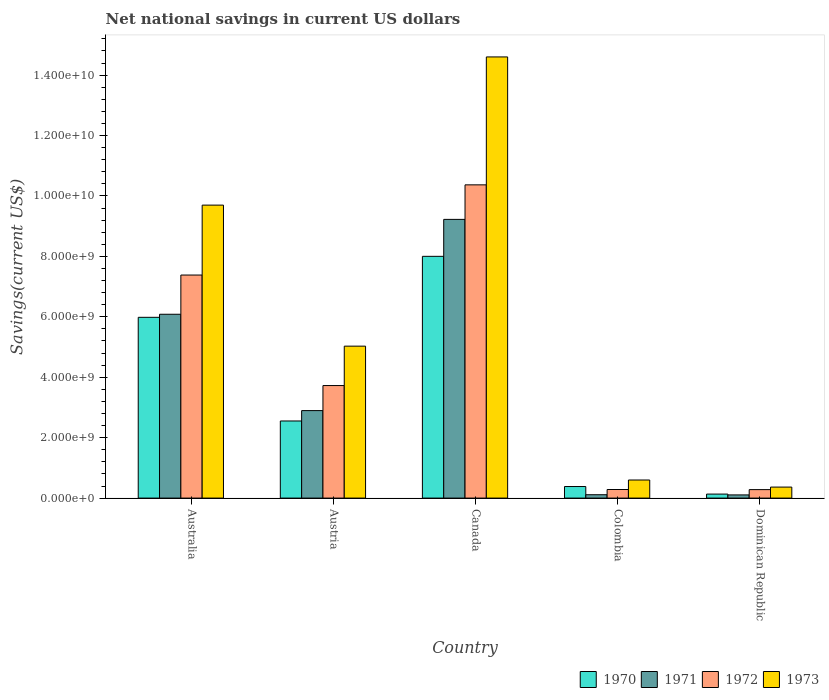Are the number of bars per tick equal to the number of legend labels?
Your response must be concise. Yes. Are the number of bars on each tick of the X-axis equal?
Keep it short and to the point. Yes. How many bars are there on the 3rd tick from the left?
Provide a succinct answer. 4. What is the label of the 5th group of bars from the left?
Keep it short and to the point. Dominican Republic. What is the net national savings in 1971 in Dominican Republic?
Offer a terse response. 1.05e+08. Across all countries, what is the maximum net national savings in 1971?
Your answer should be very brief. 9.23e+09. Across all countries, what is the minimum net national savings in 1973?
Your answer should be compact. 3.65e+08. In which country was the net national savings in 1972 maximum?
Give a very brief answer. Canada. In which country was the net national savings in 1971 minimum?
Your answer should be compact. Dominican Republic. What is the total net national savings in 1971 in the graph?
Ensure brevity in your answer.  1.84e+1. What is the difference between the net national savings in 1970 in Canada and that in Colombia?
Give a very brief answer. 7.62e+09. What is the difference between the net national savings in 1971 in Australia and the net national savings in 1972 in Austria?
Your answer should be very brief. 2.36e+09. What is the average net national savings in 1973 per country?
Your answer should be compact. 6.06e+09. What is the difference between the net national savings of/in 1970 and net national savings of/in 1971 in Austria?
Your answer should be very brief. -3.44e+08. What is the ratio of the net national savings in 1972 in Austria to that in Dominican Republic?
Keep it short and to the point. 13.28. Is the difference between the net national savings in 1970 in Australia and Canada greater than the difference between the net national savings in 1971 in Australia and Canada?
Provide a succinct answer. Yes. What is the difference between the highest and the second highest net national savings in 1970?
Offer a terse response. 3.43e+09. What is the difference between the highest and the lowest net national savings in 1970?
Make the answer very short. 7.87e+09. Is it the case that in every country, the sum of the net national savings in 1973 and net national savings in 1971 is greater than the net national savings in 1970?
Ensure brevity in your answer.  Yes. How many bars are there?
Your response must be concise. 20. Are all the bars in the graph horizontal?
Give a very brief answer. No. What is the difference between two consecutive major ticks on the Y-axis?
Make the answer very short. 2.00e+09. Are the values on the major ticks of Y-axis written in scientific E-notation?
Your answer should be very brief. Yes. Does the graph contain any zero values?
Your response must be concise. No. Does the graph contain grids?
Offer a very short reply. No. Where does the legend appear in the graph?
Your answer should be very brief. Bottom right. What is the title of the graph?
Provide a short and direct response. Net national savings in current US dollars. What is the label or title of the X-axis?
Your answer should be very brief. Country. What is the label or title of the Y-axis?
Provide a short and direct response. Savings(current US$). What is the Savings(current US$) in 1970 in Australia?
Give a very brief answer. 5.98e+09. What is the Savings(current US$) of 1971 in Australia?
Give a very brief answer. 6.09e+09. What is the Savings(current US$) in 1972 in Australia?
Make the answer very short. 7.38e+09. What is the Savings(current US$) in 1973 in Australia?
Your response must be concise. 9.70e+09. What is the Savings(current US$) in 1970 in Austria?
Make the answer very short. 2.55e+09. What is the Savings(current US$) of 1971 in Austria?
Offer a terse response. 2.90e+09. What is the Savings(current US$) of 1972 in Austria?
Your response must be concise. 3.73e+09. What is the Savings(current US$) of 1973 in Austria?
Provide a succinct answer. 5.03e+09. What is the Savings(current US$) of 1970 in Canada?
Provide a succinct answer. 8.00e+09. What is the Savings(current US$) in 1971 in Canada?
Make the answer very short. 9.23e+09. What is the Savings(current US$) in 1972 in Canada?
Make the answer very short. 1.04e+1. What is the Savings(current US$) in 1973 in Canada?
Ensure brevity in your answer.  1.46e+1. What is the Savings(current US$) of 1970 in Colombia?
Offer a very short reply. 3.83e+08. What is the Savings(current US$) in 1971 in Colombia?
Give a very brief answer. 1.11e+08. What is the Savings(current US$) of 1972 in Colombia?
Your response must be concise. 2.84e+08. What is the Savings(current US$) of 1973 in Colombia?
Keep it short and to the point. 5.98e+08. What is the Savings(current US$) of 1970 in Dominican Republic?
Your answer should be very brief. 1.33e+08. What is the Savings(current US$) of 1971 in Dominican Republic?
Make the answer very short. 1.05e+08. What is the Savings(current US$) of 1972 in Dominican Republic?
Provide a short and direct response. 2.80e+08. What is the Savings(current US$) in 1973 in Dominican Republic?
Provide a succinct answer. 3.65e+08. Across all countries, what is the maximum Savings(current US$) in 1970?
Keep it short and to the point. 8.00e+09. Across all countries, what is the maximum Savings(current US$) of 1971?
Provide a succinct answer. 9.23e+09. Across all countries, what is the maximum Savings(current US$) in 1972?
Give a very brief answer. 1.04e+1. Across all countries, what is the maximum Savings(current US$) of 1973?
Provide a short and direct response. 1.46e+1. Across all countries, what is the minimum Savings(current US$) in 1970?
Keep it short and to the point. 1.33e+08. Across all countries, what is the minimum Savings(current US$) of 1971?
Make the answer very short. 1.05e+08. Across all countries, what is the minimum Savings(current US$) of 1972?
Your response must be concise. 2.80e+08. Across all countries, what is the minimum Savings(current US$) of 1973?
Provide a short and direct response. 3.65e+08. What is the total Savings(current US$) of 1970 in the graph?
Offer a very short reply. 1.71e+1. What is the total Savings(current US$) of 1971 in the graph?
Give a very brief answer. 1.84e+1. What is the total Savings(current US$) of 1972 in the graph?
Your response must be concise. 2.20e+1. What is the total Savings(current US$) in 1973 in the graph?
Keep it short and to the point. 3.03e+1. What is the difference between the Savings(current US$) of 1970 in Australia and that in Austria?
Your answer should be very brief. 3.43e+09. What is the difference between the Savings(current US$) of 1971 in Australia and that in Austria?
Provide a succinct answer. 3.19e+09. What is the difference between the Savings(current US$) in 1972 in Australia and that in Austria?
Make the answer very short. 3.66e+09. What is the difference between the Savings(current US$) of 1973 in Australia and that in Austria?
Offer a terse response. 4.67e+09. What is the difference between the Savings(current US$) of 1970 in Australia and that in Canada?
Offer a very short reply. -2.02e+09. What is the difference between the Savings(current US$) in 1971 in Australia and that in Canada?
Keep it short and to the point. -3.14e+09. What is the difference between the Savings(current US$) in 1972 in Australia and that in Canada?
Ensure brevity in your answer.  -2.99e+09. What is the difference between the Savings(current US$) of 1973 in Australia and that in Canada?
Your response must be concise. -4.90e+09. What is the difference between the Savings(current US$) of 1970 in Australia and that in Colombia?
Keep it short and to the point. 5.60e+09. What is the difference between the Savings(current US$) of 1971 in Australia and that in Colombia?
Provide a short and direct response. 5.97e+09. What is the difference between the Savings(current US$) in 1972 in Australia and that in Colombia?
Offer a very short reply. 7.10e+09. What is the difference between the Savings(current US$) in 1973 in Australia and that in Colombia?
Provide a short and direct response. 9.10e+09. What is the difference between the Savings(current US$) of 1970 in Australia and that in Dominican Republic?
Offer a very short reply. 5.85e+09. What is the difference between the Savings(current US$) in 1971 in Australia and that in Dominican Republic?
Give a very brief answer. 5.98e+09. What is the difference between the Savings(current US$) of 1972 in Australia and that in Dominican Republic?
Give a very brief answer. 7.10e+09. What is the difference between the Savings(current US$) in 1973 in Australia and that in Dominican Republic?
Keep it short and to the point. 9.33e+09. What is the difference between the Savings(current US$) in 1970 in Austria and that in Canada?
Your response must be concise. -5.45e+09. What is the difference between the Savings(current US$) of 1971 in Austria and that in Canada?
Your answer should be very brief. -6.33e+09. What is the difference between the Savings(current US$) in 1972 in Austria and that in Canada?
Offer a very short reply. -6.64e+09. What is the difference between the Savings(current US$) in 1973 in Austria and that in Canada?
Your answer should be compact. -9.57e+09. What is the difference between the Savings(current US$) in 1970 in Austria and that in Colombia?
Your response must be concise. 2.17e+09. What is the difference between the Savings(current US$) of 1971 in Austria and that in Colombia?
Your answer should be compact. 2.78e+09. What is the difference between the Savings(current US$) of 1972 in Austria and that in Colombia?
Your answer should be very brief. 3.44e+09. What is the difference between the Savings(current US$) in 1973 in Austria and that in Colombia?
Keep it short and to the point. 4.43e+09. What is the difference between the Savings(current US$) in 1970 in Austria and that in Dominican Republic?
Make the answer very short. 2.42e+09. What is the difference between the Savings(current US$) of 1971 in Austria and that in Dominican Republic?
Provide a short and direct response. 2.79e+09. What is the difference between the Savings(current US$) in 1972 in Austria and that in Dominican Republic?
Your answer should be very brief. 3.44e+09. What is the difference between the Savings(current US$) of 1973 in Austria and that in Dominican Republic?
Ensure brevity in your answer.  4.66e+09. What is the difference between the Savings(current US$) in 1970 in Canada and that in Colombia?
Ensure brevity in your answer.  7.62e+09. What is the difference between the Savings(current US$) in 1971 in Canada and that in Colombia?
Offer a terse response. 9.11e+09. What is the difference between the Savings(current US$) in 1972 in Canada and that in Colombia?
Make the answer very short. 1.01e+1. What is the difference between the Savings(current US$) in 1973 in Canada and that in Colombia?
Offer a terse response. 1.40e+1. What is the difference between the Savings(current US$) of 1970 in Canada and that in Dominican Republic?
Give a very brief answer. 7.87e+09. What is the difference between the Savings(current US$) of 1971 in Canada and that in Dominican Republic?
Offer a very short reply. 9.12e+09. What is the difference between the Savings(current US$) in 1972 in Canada and that in Dominican Republic?
Give a very brief answer. 1.01e+1. What is the difference between the Savings(current US$) in 1973 in Canada and that in Dominican Republic?
Provide a succinct answer. 1.42e+1. What is the difference between the Savings(current US$) in 1970 in Colombia and that in Dominican Republic?
Your answer should be very brief. 2.50e+08. What is the difference between the Savings(current US$) in 1971 in Colombia and that in Dominican Republic?
Offer a terse response. 6.03e+06. What is the difference between the Savings(current US$) of 1972 in Colombia and that in Dominican Republic?
Provide a succinct answer. 3.48e+06. What is the difference between the Savings(current US$) of 1973 in Colombia and that in Dominican Republic?
Ensure brevity in your answer.  2.34e+08. What is the difference between the Savings(current US$) in 1970 in Australia and the Savings(current US$) in 1971 in Austria?
Give a very brief answer. 3.09e+09. What is the difference between the Savings(current US$) of 1970 in Australia and the Savings(current US$) of 1972 in Austria?
Your answer should be very brief. 2.26e+09. What is the difference between the Savings(current US$) in 1970 in Australia and the Savings(current US$) in 1973 in Austria?
Keep it short and to the point. 9.54e+08. What is the difference between the Savings(current US$) of 1971 in Australia and the Savings(current US$) of 1972 in Austria?
Offer a terse response. 2.36e+09. What is the difference between the Savings(current US$) of 1971 in Australia and the Savings(current US$) of 1973 in Austria?
Offer a terse response. 1.06e+09. What is the difference between the Savings(current US$) in 1972 in Australia and the Savings(current US$) in 1973 in Austria?
Offer a very short reply. 2.35e+09. What is the difference between the Savings(current US$) in 1970 in Australia and the Savings(current US$) in 1971 in Canada?
Give a very brief answer. -3.24e+09. What is the difference between the Savings(current US$) in 1970 in Australia and the Savings(current US$) in 1972 in Canada?
Provide a short and direct response. -4.38e+09. What is the difference between the Savings(current US$) in 1970 in Australia and the Savings(current US$) in 1973 in Canada?
Keep it short and to the point. -8.62e+09. What is the difference between the Savings(current US$) of 1971 in Australia and the Savings(current US$) of 1972 in Canada?
Your answer should be compact. -4.28e+09. What is the difference between the Savings(current US$) in 1971 in Australia and the Savings(current US$) in 1973 in Canada?
Provide a succinct answer. -8.52e+09. What is the difference between the Savings(current US$) in 1972 in Australia and the Savings(current US$) in 1973 in Canada?
Your response must be concise. -7.22e+09. What is the difference between the Savings(current US$) in 1970 in Australia and the Savings(current US$) in 1971 in Colombia?
Offer a terse response. 5.87e+09. What is the difference between the Savings(current US$) in 1970 in Australia and the Savings(current US$) in 1972 in Colombia?
Make the answer very short. 5.70e+09. What is the difference between the Savings(current US$) in 1970 in Australia and the Savings(current US$) in 1973 in Colombia?
Make the answer very short. 5.38e+09. What is the difference between the Savings(current US$) in 1971 in Australia and the Savings(current US$) in 1972 in Colombia?
Offer a very short reply. 5.80e+09. What is the difference between the Savings(current US$) in 1971 in Australia and the Savings(current US$) in 1973 in Colombia?
Provide a short and direct response. 5.49e+09. What is the difference between the Savings(current US$) of 1972 in Australia and the Savings(current US$) of 1973 in Colombia?
Ensure brevity in your answer.  6.78e+09. What is the difference between the Savings(current US$) of 1970 in Australia and the Savings(current US$) of 1971 in Dominican Republic?
Keep it short and to the point. 5.88e+09. What is the difference between the Savings(current US$) in 1970 in Australia and the Savings(current US$) in 1972 in Dominican Republic?
Your response must be concise. 5.70e+09. What is the difference between the Savings(current US$) in 1970 in Australia and the Savings(current US$) in 1973 in Dominican Republic?
Provide a short and direct response. 5.62e+09. What is the difference between the Savings(current US$) of 1971 in Australia and the Savings(current US$) of 1972 in Dominican Republic?
Your answer should be compact. 5.80e+09. What is the difference between the Savings(current US$) of 1971 in Australia and the Savings(current US$) of 1973 in Dominican Republic?
Ensure brevity in your answer.  5.72e+09. What is the difference between the Savings(current US$) in 1972 in Australia and the Savings(current US$) in 1973 in Dominican Republic?
Ensure brevity in your answer.  7.02e+09. What is the difference between the Savings(current US$) in 1970 in Austria and the Savings(current US$) in 1971 in Canada?
Your response must be concise. -6.67e+09. What is the difference between the Savings(current US$) in 1970 in Austria and the Savings(current US$) in 1972 in Canada?
Your answer should be very brief. -7.82e+09. What is the difference between the Savings(current US$) of 1970 in Austria and the Savings(current US$) of 1973 in Canada?
Ensure brevity in your answer.  -1.20e+1. What is the difference between the Savings(current US$) in 1971 in Austria and the Savings(current US$) in 1972 in Canada?
Provide a succinct answer. -7.47e+09. What is the difference between the Savings(current US$) of 1971 in Austria and the Savings(current US$) of 1973 in Canada?
Your answer should be very brief. -1.17e+1. What is the difference between the Savings(current US$) in 1972 in Austria and the Savings(current US$) in 1973 in Canada?
Your response must be concise. -1.09e+1. What is the difference between the Savings(current US$) in 1970 in Austria and the Savings(current US$) in 1971 in Colombia?
Provide a short and direct response. 2.44e+09. What is the difference between the Savings(current US$) in 1970 in Austria and the Savings(current US$) in 1972 in Colombia?
Give a very brief answer. 2.27e+09. What is the difference between the Savings(current US$) in 1970 in Austria and the Savings(current US$) in 1973 in Colombia?
Your response must be concise. 1.95e+09. What is the difference between the Savings(current US$) in 1971 in Austria and the Savings(current US$) in 1972 in Colombia?
Make the answer very short. 2.61e+09. What is the difference between the Savings(current US$) in 1971 in Austria and the Savings(current US$) in 1973 in Colombia?
Provide a succinct answer. 2.30e+09. What is the difference between the Savings(current US$) in 1972 in Austria and the Savings(current US$) in 1973 in Colombia?
Offer a terse response. 3.13e+09. What is the difference between the Savings(current US$) of 1970 in Austria and the Savings(current US$) of 1971 in Dominican Republic?
Your answer should be compact. 2.45e+09. What is the difference between the Savings(current US$) in 1970 in Austria and the Savings(current US$) in 1972 in Dominican Republic?
Your answer should be very brief. 2.27e+09. What is the difference between the Savings(current US$) in 1970 in Austria and the Savings(current US$) in 1973 in Dominican Republic?
Give a very brief answer. 2.19e+09. What is the difference between the Savings(current US$) in 1971 in Austria and the Savings(current US$) in 1972 in Dominican Republic?
Give a very brief answer. 2.62e+09. What is the difference between the Savings(current US$) of 1971 in Austria and the Savings(current US$) of 1973 in Dominican Republic?
Offer a terse response. 2.53e+09. What is the difference between the Savings(current US$) of 1972 in Austria and the Savings(current US$) of 1973 in Dominican Republic?
Ensure brevity in your answer.  3.36e+09. What is the difference between the Savings(current US$) in 1970 in Canada and the Savings(current US$) in 1971 in Colombia?
Offer a very short reply. 7.89e+09. What is the difference between the Savings(current US$) in 1970 in Canada and the Savings(current US$) in 1972 in Colombia?
Provide a succinct answer. 7.72e+09. What is the difference between the Savings(current US$) of 1970 in Canada and the Savings(current US$) of 1973 in Colombia?
Make the answer very short. 7.40e+09. What is the difference between the Savings(current US$) in 1971 in Canada and the Savings(current US$) in 1972 in Colombia?
Keep it short and to the point. 8.94e+09. What is the difference between the Savings(current US$) of 1971 in Canada and the Savings(current US$) of 1973 in Colombia?
Provide a succinct answer. 8.63e+09. What is the difference between the Savings(current US$) of 1972 in Canada and the Savings(current US$) of 1973 in Colombia?
Provide a short and direct response. 9.77e+09. What is the difference between the Savings(current US$) in 1970 in Canada and the Savings(current US$) in 1971 in Dominican Republic?
Your response must be concise. 7.90e+09. What is the difference between the Savings(current US$) in 1970 in Canada and the Savings(current US$) in 1972 in Dominican Republic?
Offer a terse response. 7.72e+09. What is the difference between the Savings(current US$) in 1970 in Canada and the Savings(current US$) in 1973 in Dominican Republic?
Offer a terse response. 7.64e+09. What is the difference between the Savings(current US$) in 1971 in Canada and the Savings(current US$) in 1972 in Dominican Republic?
Your answer should be compact. 8.94e+09. What is the difference between the Savings(current US$) of 1971 in Canada and the Savings(current US$) of 1973 in Dominican Republic?
Provide a succinct answer. 8.86e+09. What is the difference between the Savings(current US$) in 1972 in Canada and the Savings(current US$) in 1973 in Dominican Republic?
Your response must be concise. 1.00e+1. What is the difference between the Savings(current US$) of 1970 in Colombia and the Savings(current US$) of 1971 in Dominican Republic?
Make the answer very short. 2.77e+08. What is the difference between the Savings(current US$) in 1970 in Colombia and the Savings(current US$) in 1972 in Dominican Republic?
Ensure brevity in your answer.  1.02e+08. What is the difference between the Savings(current US$) in 1970 in Colombia and the Savings(current US$) in 1973 in Dominican Republic?
Ensure brevity in your answer.  1.82e+07. What is the difference between the Savings(current US$) in 1971 in Colombia and the Savings(current US$) in 1972 in Dominican Republic?
Keep it short and to the point. -1.69e+08. What is the difference between the Savings(current US$) in 1971 in Colombia and the Savings(current US$) in 1973 in Dominican Republic?
Your answer should be very brief. -2.53e+08. What is the difference between the Savings(current US$) in 1972 in Colombia and the Savings(current US$) in 1973 in Dominican Republic?
Offer a terse response. -8.05e+07. What is the average Savings(current US$) in 1970 per country?
Provide a short and direct response. 3.41e+09. What is the average Savings(current US$) of 1971 per country?
Your answer should be very brief. 3.68e+09. What is the average Savings(current US$) in 1972 per country?
Your response must be concise. 4.41e+09. What is the average Savings(current US$) of 1973 per country?
Ensure brevity in your answer.  6.06e+09. What is the difference between the Savings(current US$) of 1970 and Savings(current US$) of 1971 in Australia?
Your answer should be compact. -1.02e+08. What is the difference between the Savings(current US$) in 1970 and Savings(current US$) in 1972 in Australia?
Your response must be concise. -1.40e+09. What is the difference between the Savings(current US$) of 1970 and Savings(current US$) of 1973 in Australia?
Offer a very short reply. -3.71e+09. What is the difference between the Savings(current US$) of 1971 and Savings(current US$) of 1972 in Australia?
Keep it short and to the point. -1.30e+09. What is the difference between the Savings(current US$) in 1971 and Savings(current US$) in 1973 in Australia?
Make the answer very short. -3.61e+09. What is the difference between the Savings(current US$) of 1972 and Savings(current US$) of 1973 in Australia?
Keep it short and to the point. -2.31e+09. What is the difference between the Savings(current US$) of 1970 and Savings(current US$) of 1971 in Austria?
Offer a terse response. -3.44e+08. What is the difference between the Savings(current US$) of 1970 and Savings(current US$) of 1972 in Austria?
Your response must be concise. -1.17e+09. What is the difference between the Savings(current US$) in 1970 and Savings(current US$) in 1973 in Austria?
Ensure brevity in your answer.  -2.48e+09. What is the difference between the Savings(current US$) in 1971 and Savings(current US$) in 1972 in Austria?
Ensure brevity in your answer.  -8.29e+08. What is the difference between the Savings(current US$) in 1971 and Savings(current US$) in 1973 in Austria?
Your answer should be very brief. -2.13e+09. What is the difference between the Savings(current US$) of 1972 and Savings(current US$) of 1973 in Austria?
Give a very brief answer. -1.30e+09. What is the difference between the Savings(current US$) in 1970 and Savings(current US$) in 1971 in Canada?
Keep it short and to the point. -1.22e+09. What is the difference between the Savings(current US$) of 1970 and Savings(current US$) of 1972 in Canada?
Give a very brief answer. -2.37e+09. What is the difference between the Savings(current US$) in 1970 and Savings(current US$) in 1973 in Canada?
Offer a very short reply. -6.60e+09. What is the difference between the Savings(current US$) of 1971 and Savings(current US$) of 1972 in Canada?
Your response must be concise. -1.14e+09. What is the difference between the Savings(current US$) of 1971 and Savings(current US$) of 1973 in Canada?
Keep it short and to the point. -5.38e+09. What is the difference between the Savings(current US$) in 1972 and Savings(current US$) in 1973 in Canada?
Ensure brevity in your answer.  -4.23e+09. What is the difference between the Savings(current US$) of 1970 and Savings(current US$) of 1971 in Colombia?
Provide a succinct answer. 2.71e+08. What is the difference between the Savings(current US$) in 1970 and Savings(current US$) in 1972 in Colombia?
Give a very brief answer. 9.87e+07. What is the difference between the Savings(current US$) in 1970 and Savings(current US$) in 1973 in Colombia?
Your answer should be compact. -2.16e+08. What is the difference between the Savings(current US$) of 1971 and Savings(current US$) of 1972 in Colombia?
Give a very brief answer. -1.73e+08. What is the difference between the Savings(current US$) in 1971 and Savings(current US$) in 1973 in Colombia?
Keep it short and to the point. -4.87e+08. What is the difference between the Savings(current US$) of 1972 and Savings(current US$) of 1973 in Colombia?
Provide a succinct answer. -3.14e+08. What is the difference between the Savings(current US$) of 1970 and Savings(current US$) of 1971 in Dominican Republic?
Offer a terse response. 2.74e+07. What is the difference between the Savings(current US$) of 1970 and Savings(current US$) of 1972 in Dominican Republic?
Ensure brevity in your answer.  -1.48e+08. What is the difference between the Savings(current US$) in 1970 and Savings(current US$) in 1973 in Dominican Republic?
Your response must be concise. -2.32e+08. What is the difference between the Savings(current US$) of 1971 and Savings(current US$) of 1972 in Dominican Republic?
Keep it short and to the point. -1.75e+08. What is the difference between the Savings(current US$) of 1971 and Savings(current US$) of 1973 in Dominican Republic?
Offer a terse response. -2.59e+08. What is the difference between the Savings(current US$) of 1972 and Savings(current US$) of 1973 in Dominican Republic?
Keep it short and to the point. -8.40e+07. What is the ratio of the Savings(current US$) of 1970 in Australia to that in Austria?
Your answer should be compact. 2.34. What is the ratio of the Savings(current US$) in 1971 in Australia to that in Austria?
Your answer should be compact. 2.1. What is the ratio of the Savings(current US$) in 1972 in Australia to that in Austria?
Provide a short and direct response. 1.98. What is the ratio of the Savings(current US$) in 1973 in Australia to that in Austria?
Your answer should be very brief. 1.93. What is the ratio of the Savings(current US$) of 1970 in Australia to that in Canada?
Offer a very short reply. 0.75. What is the ratio of the Savings(current US$) in 1971 in Australia to that in Canada?
Offer a very short reply. 0.66. What is the ratio of the Savings(current US$) in 1972 in Australia to that in Canada?
Your answer should be compact. 0.71. What is the ratio of the Savings(current US$) of 1973 in Australia to that in Canada?
Provide a succinct answer. 0.66. What is the ratio of the Savings(current US$) in 1970 in Australia to that in Colombia?
Offer a terse response. 15.64. What is the ratio of the Savings(current US$) of 1971 in Australia to that in Colombia?
Your answer should be compact. 54.61. What is the ratio of the Savings(current US$) of 1972 in Australia to that in Colombia?
Keep it short and to the point. 26. What is the ratio of the Savings(current US$) of 1973 in Australia to that in Colombia?
Ensure brevity in your answer.  16.2. What is the ratio of the Savings(current US$) in 1970 in Australia to that in Dominican Republic?
Provide a short and direct response. 45.07. What is the ratio of the Savings(current US$) of 1971 in Australia to that in Dominican Republic?
Offer a very short reply. 57.73. What is the ratio of the Savings(current US$) in 1972 in Australia to that in Dominican Republic?
Your response must be concise. 26.32. What is the ratio of the Savings(current US$) of 1973 in Australia to that in Dominican Republic?
Your answer should be very brief. 26.6. What is the ratio of the Savings(current US$) of 1970 in Austria to that in Canada?
Offer a very short reply. 0.32. What is the ratio of the Savings(current US$) of 1971 in Austria to that in Canada?
Provide a short and direct response. 0.31. What is the ratio of the Savings(current US$) of 1972 in Austria to that in Canada?
Your answer should be very brief. 0.36. What is the ratio of the Savings(current US$) in 1973 in Austria to that in Canada?
Make the answer very short. 0.34. What is the ratio of the Savings(current US$) in 1970 in Austria to that in Colombia?
Your response must be concise. 6.67. What is the ratio of the Savings(current US$) in 1971 in Austria to that in Colombia?
Your answer should be very brief. 25.99. What is the ratio of the Savings(current US$) in 1972 in Austria to that in Colombia?
Provide a succinct answer. 13.12. What is the ratio of the Savings(current US$) of 1973 in Austria to that in Colombia?
Your response must be concise. 8.4. What is the ratio of the Savings(current US$) of 1970 in Austria to that in Dominican Republic?
Offer a terse response. 19.23. What is the ratio of the Savings(current US$) in 1971 in Austria to that in Dominican Republic?
Offer a very short reply. 27.48. What is the ratio of the Savings(current US$) in 1972 in Austria to that in Dominican Republic?
Provide a succinct answer. 13.28. What is the ratio of the Savings(current US$) in 1973 in Austria to that in Dominican Republic?
Ensure brevity in your answer.  13.8. What is the ratio of the Savings(current US$) in 1970 in Canada to that in Colombia?
Offer a terse response. 20.91. What is the ratio of the Savings(current US$) of 1971 in Canada to that in Colombia?
Your answer should be very brief. 82.79. What is the ratio of the Savings(current US$) in 1972 in Canada to that in Colombia?
Ensure brevity in your answer.  36.51. What is the ratio of the Savings(current US$) of 1973 in Canada to that in Colombia?
Provide a short and direct response. 24.4. What is the ratio of the Savings(current US$) in 1970 in Canada to that in Dominican Republic?
Your response must be concise. 60.27. What is the ratio of the Savings(current US$) in 1971 in Canada to that in Dominican Republic?
Your answer should be very brief. 87.52. What is the ratio of the Savings(current US$) of 1972 in Canada to that in Dominican Republic?
Make the answer very short. 36.96. What is the ratio of the Savings(current US$) in 1973 in Canada to that in Dominican Republic?
Make the answer very short. 40.06. What is the ratio of the Savings(current US$) in 1970 in Colombia to that in Dominican Republic?
Provide a short and direct response. 2.88. What is the ratio of the Savings(current US$) in 1971 in Colombia to that in Dominican Republic?
Your answer should be compact. 1.06. What is the ratio of the Savings(current US$) of 1972 in Colombia to that in Dominican Republic?
Provide a short and direct response. 1.01. What is the ratio of the Savings(current US$) of 1973 in Colombia to that in Dominican Republic?
Offer a very short reply. 1.64. What is the difference between the highest and the second highest Savings(current US$) of 1970?
Your response must be concise. 2.02e+09. What is the difference between the highest and the second highest Savings(current US$) in 1971?
Offer a terse response. 3.14e+09. What is the difference between the highest and the second highest Savings(current US$) of 1972?
Your response must be concise. 2.99e+09. What is the difference between the highest and the second highest Savings(current US$) of 1973?
Offer a terse response. 4.90e+09. What is the difference between the highest and the lowest Savings(current US$) in 1970?
Provide a succinct answer. 7.87e+09. What is the difference between the highest and the lowest Savings(current US$) in 1971?
Your answer should be very brief. 9.12e+09. What is the difference between the highest and the lowest Savings(current US$) of 1972?
Give a very brief answer. 1.01e+1. What is the difference between the highest and the lowest Savings(current US$) of 1973?
Provide a short and direct response. 1.42e+1. 